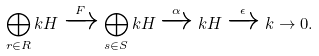<formula> <loc_0><loc_0><loc_500><loc_500>\bigoplus _ { r \in R } k H \xrightarrow { F } \bigoplus _ { s \in S } k H \xrightarrow { \alpha } k H \xrightarrow { \epsilon } k \to 0 .</formula> 